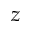<formula> <loc_0><loc_0><loc_500><loc_500>z</formula> 